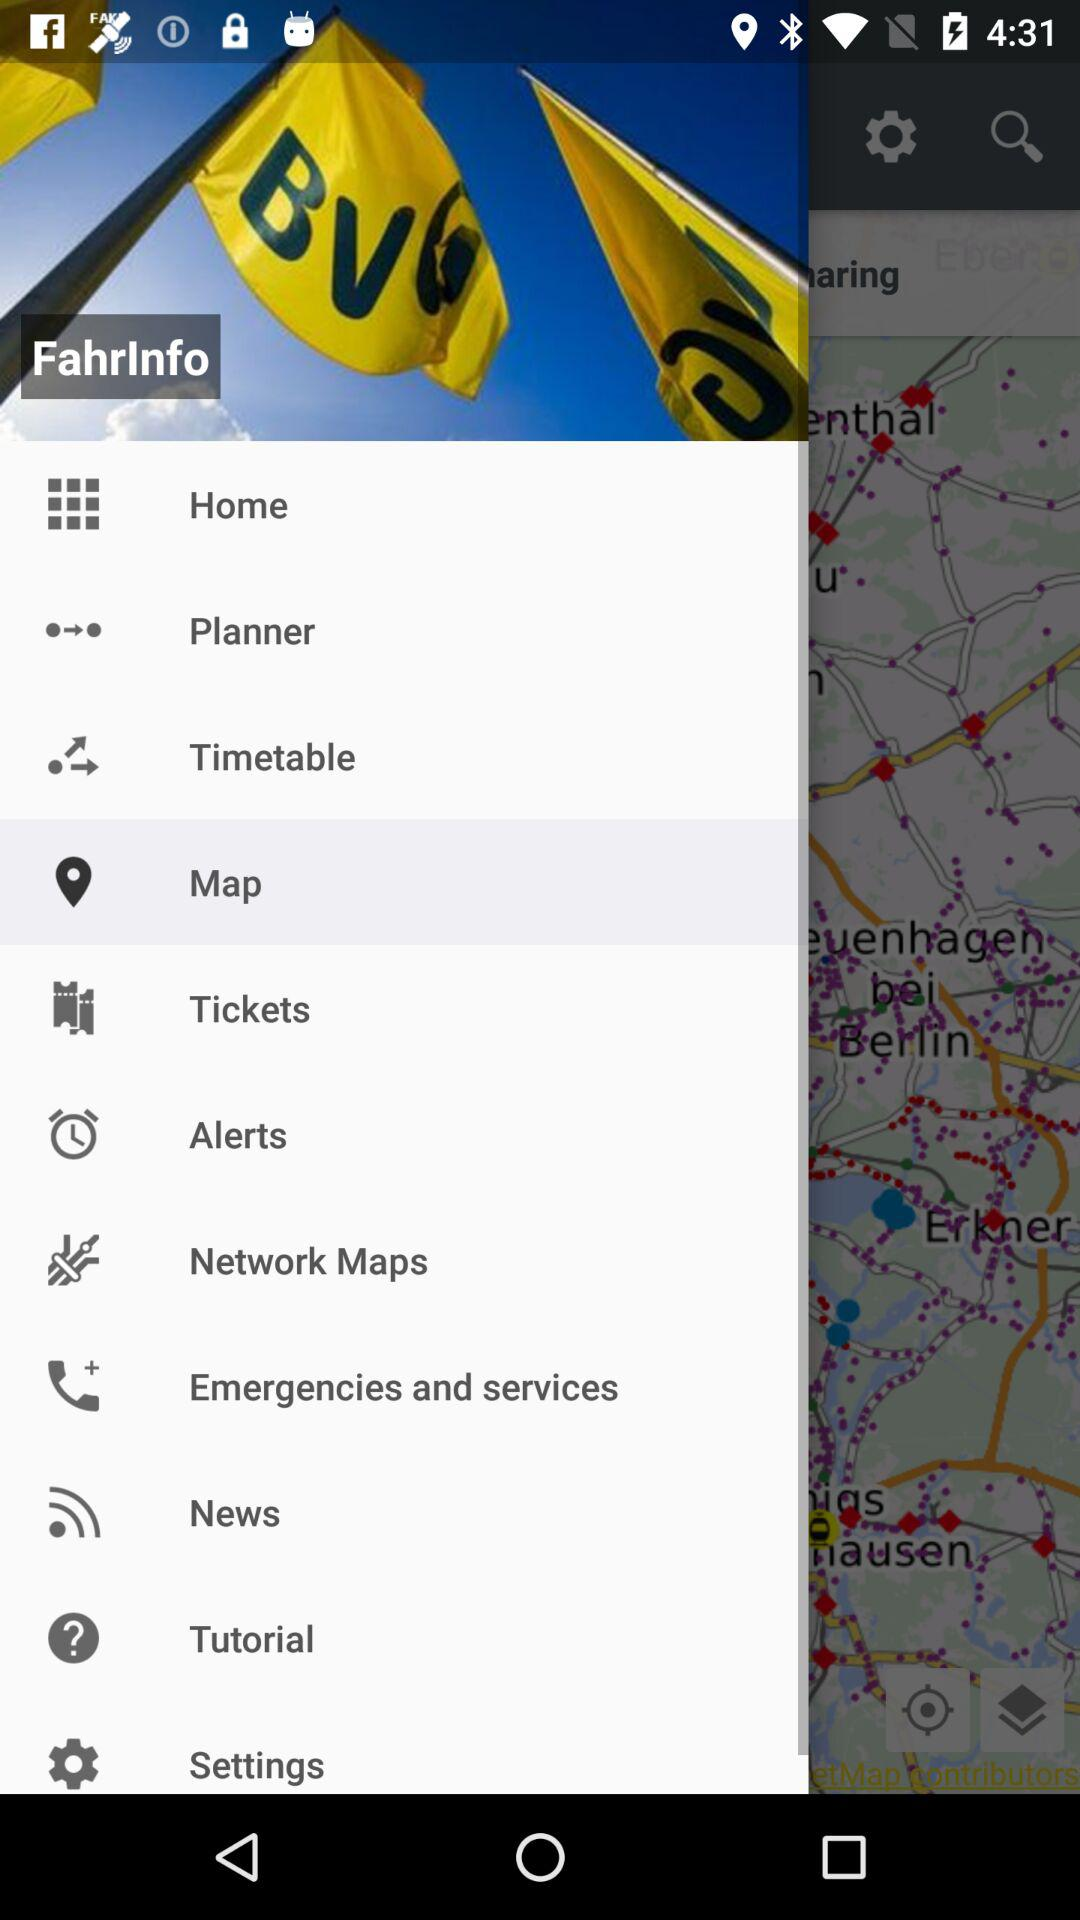Which item has been selected? The item that has been selected is "Map". 